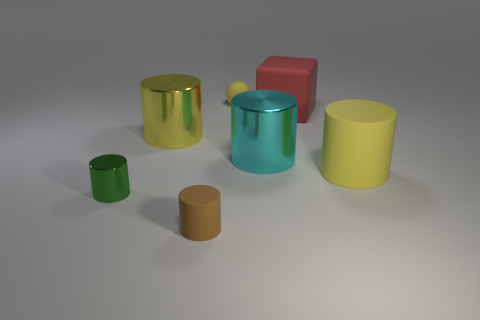What can you infer about the texture of the objects? The objects have distinguishable textures upon closer inspection. The yellow and cyan cylinders exhibit a shiny texture, indicated by the reflections and highlights on their surfaces, whereas the green ball and cylinder have a matte finish with more diffused light, lacking prominent reflections. 